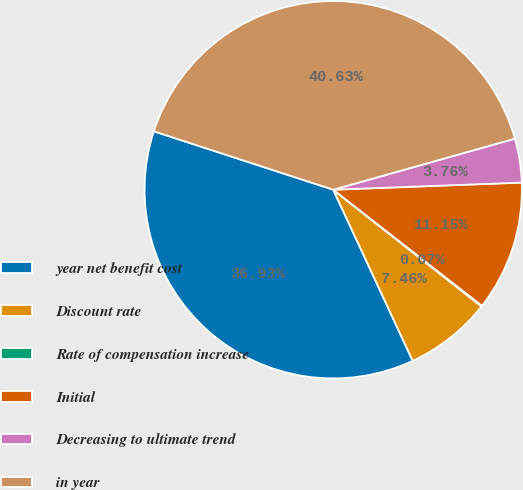Convert chart to OTSL. <chart><loc_0><loc_0><loc_500><loc_500><pie_chart><fcel>year net benefit cost<fcel>Discount rate<fcel>Rate of compensation increase<fcel>Initial<fcel>Decreasing to ultimate trend<fcel>in year<nl><fcel>36.93%<fcel>7.46%<fcel>0.07%<fcel>11.15%<fcel>3.76%<fcel>40.63%<nl></chart> 